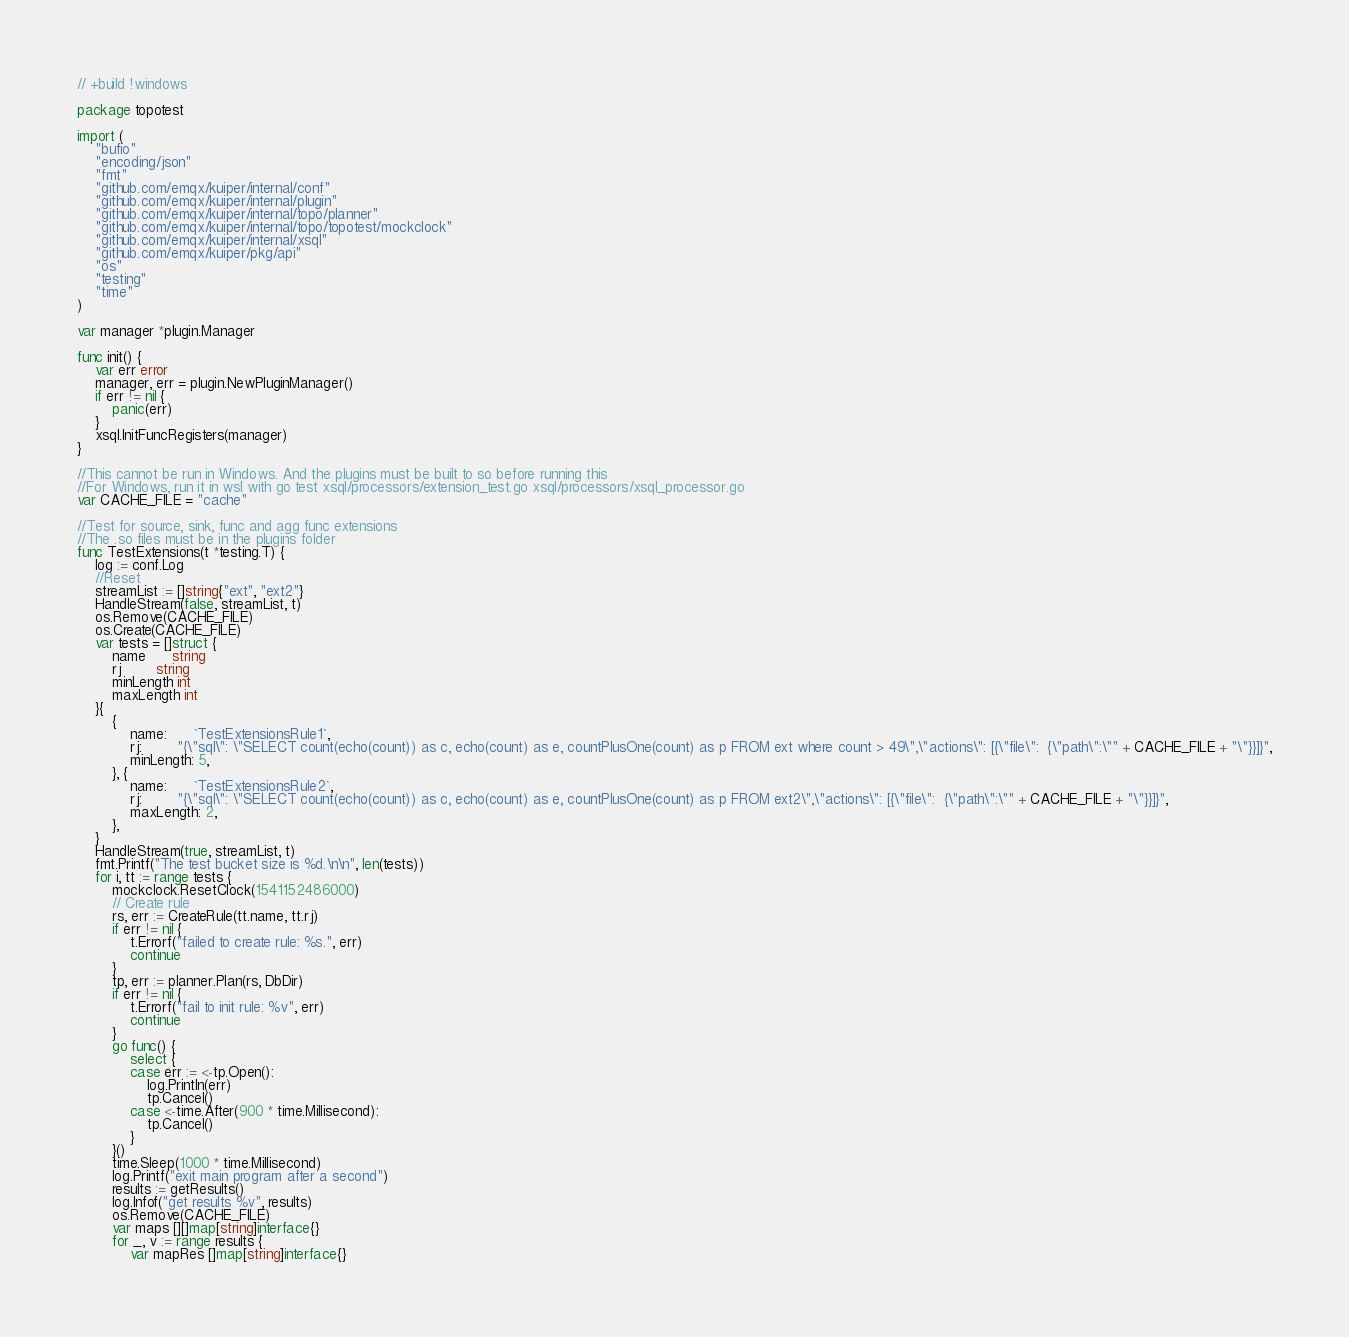Convert code to text. <code><loc_0><loc_0><loc_500><loc_500><_Go_>// +build !windows

package topotest

import (
	"bufio"
	"encoding/json"
	"fmt"
	"github.com/emqx/kuiper/internal/conf"
	"github.com/emqx/kuiper/internal/plugin"
	"github.com/emqx/kuiper/internal/topo/planner"
	"github.com/emqx/kuiper/internal/topo/topotest/mockclock"
	"github.com/emqx/kuiper/internal/xsql"
	"github.com/emqx/kuiper/pkg/api"
	"os"
	"testing"
	"time"
)

var manager *plugin.Manager

func init() {
	var err error
	manager, err = plugin.NewPluginManager()
	if err != nil {
		panic(err)
	}
	xsql.InitFuncRegisters(manager)
}

//This cannot be run in Windows. And the plugins must be built to so before running this
//For Windows, run it in wsl with go test xsql/processors/extension_test.go xsql/processors/xsql_processor.go
var CACHE_FILE = "cache"

//Test for source, sink, func and agg func extensions
//The .so files must be in the plugins folder
func TestExtensions(t *testing.T) {
	log := conf.Log
	//Reset
	streamList := []string{"ext", "ext2"}
	HandleStream(false, streamList, t)
	os.Remove(CACHE_FILE)
	os.Create(CACHE_FILE)
	var tests = []struct {
		name      string
		rj        string
		minLength int
		maxLength int
	}{
		{
			name:      `TestExtensionsRule1`,
			rj:        "{\"sql\": \"SELECT count(echo(count)) as c, echo(count) as e, countPlusOne(count) as p FROM ext where count > 49\",\"actions\": [{\"file\":  {\"path\":\"" + CACHE_FILE + "\"}}]}",
			minLength: 5,
		}, {
			name:      `TestExtensionsRule2`,
			rj:        "{\"sql\": \"SELECT count(echo(count)) as c, echo(count) as e, countPlusOne(count) as p FROM ext2\",\"actions\": [{\"file\":  {\"path\":\"" + CACHE_FILE + "\"}}]}",
			maxLength: 2,
		},
	}
	HandleStream(true, streamList, t)
	fmt.Printf("The test bucket size is %d.\n\n", len(tests))
	for i, tt := range tests {
		mockclock.ResetClock(1541152486000)
		// Create rule
		rs, err := CreateRule(tt.name, tt.rj)
		if err != nil {
			t.Errorf("failed to create rule: %s.", err)
			continue
		}
		tp, err := planner.Plan(rs, DbDir)
		if err != nil {
			t.Errorf("fail to init rule: %v", err)
			continue
		}
		go func() {
			select {
			case err := <-tp.Open():
				log.Println(err)
				tp.Cancel()
			case <-time.After(900 * time.Millisecond):
				tp.Cancel()
			}
		}()
		time.Sleep(1000 * time.Millisecond)
		log.Printf("exit main program after a second")
		results := getResults()
		log.Infof("get results %v", results)
		os.Remove(CACHE_FILE)
		var maps [][]map[string]interface{}
		for _, v := range results {
			var mapRes []map[string]interface{}</code> 